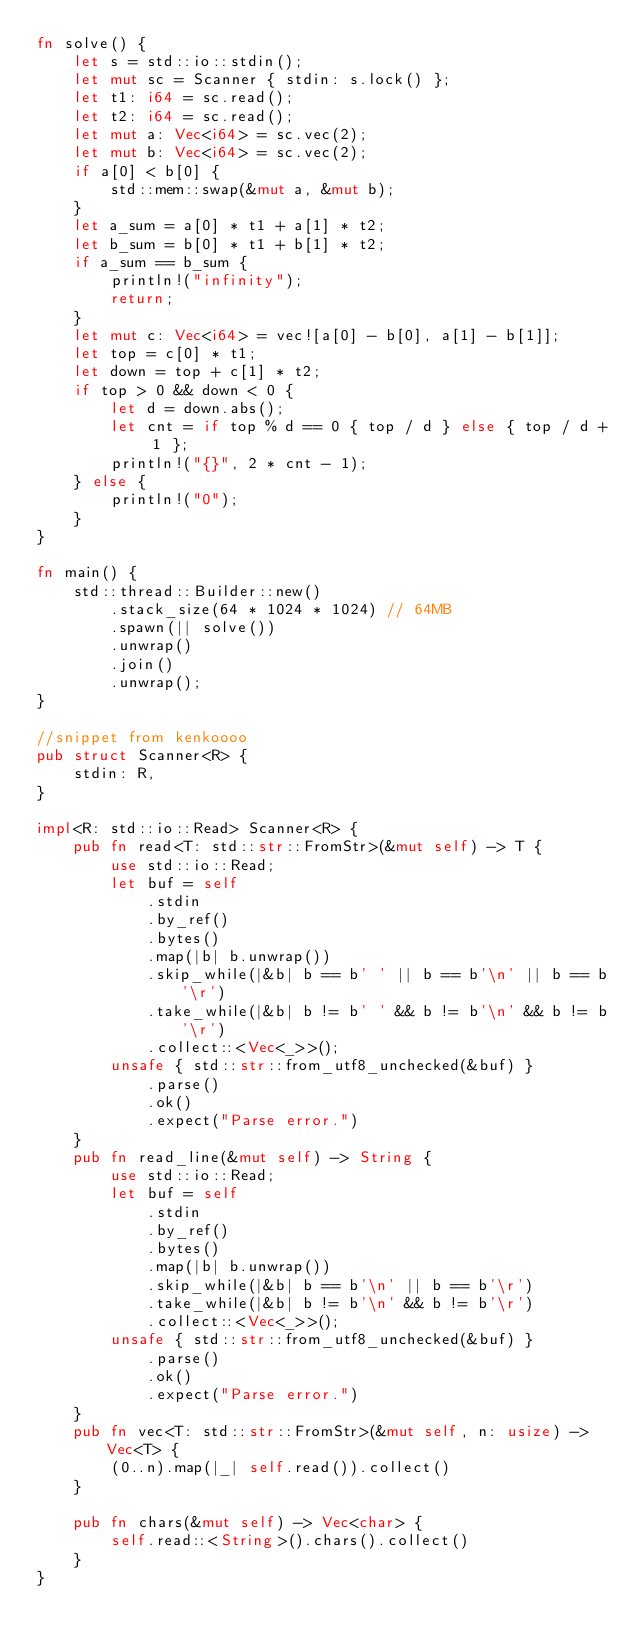<code> <loc_0><loc_0><loc_500><loc_500><_Rust_>fn solve() {
    let s = std::io::stdin();
    let mut sc = Scanner { stdin: s.lock() };
    let t1: i64 = sc.read();
    let t2: i64 = sc.read();
    let mut a: Vec<i64> = sc.vec(2);
    let mut b: Vec<i64> = sc.vec(2);
    if a[0] < b[0] {
        std::mem::swap(&mut a, &mut b);
    }
    let a_sum = a[0] * t1 + a[1] * t2;
    let b_sum = b[0] * t1 + b[1] * t2;
    if a_sum == b_sum {
        println!("infinity");
        return;
    }
    let mut c: Vec<i64> = vec![a[0] - b[0], a[1] - b[1]];
    let top = c[0] * t1;
    let down = top + c[1] * t2;
    if top > 0 && down < 0 {
        let d = down.abs();
        let cnt = if top % d == 0 { top / d } else { top / d + 1 };
        println!("{}", 2 * cnt - 1);
    } else {
        println!("0");
    }
}

fn main() {
    std::thread::Builder::new()
        .stack_size(64 * 1024 * 1024) // 64MB
        .spawn(|| solve())
        .unwrap()
        .join()
        .unwrap();
}

//snippet from kenkoooo
pub struct Scanner<R> {
    stdin: R,
}

impl<R: std::io::Read> Scanner<R> {
    pub fn read<T: std::str::FromStr>(&mut self) -> T {
        use std::io::Read;
        let buf = self
            .stdin
            .by_ref()
            .bytes()
            .map(|b| b.unwrap())
            .skip_while(|&b| b == b' ' || b == b'\n' || b == b'\r')
            .take_while(|&b| b != b' ' && b != b'\n' && b != b'\r')
            .collect::<Vec<_>>();
        unsafe { std::str::from_utf8_unchecked(&buf) }
            .parse()
            .ok()
            .expect("Parse error.")
    }
    pub fn read_line(&mut self) -> String {
        use std::io::Read;
        let buf = self
            .stdin
            .by_ref()
            .bytes()
            .map(|b| b.unwrap())
            .skip_while(|&b| b == b'\n' || b == b'\r')
            .take_while(|&b| b != b'\n' && b != b'\r')
            .collect::<Vec<_>>();
        unsafe { std::str::from_utf8_unchecked(&buf) }
            .parse()
            .ok()
            .expect("Parse error.")
    }
    pub fn vec<T: std::str::FromStr>(&mut self, n: usize) -> Vec<T> {
        (0..n).map(|_| self.read()).collect()
    }

    pub fn chars(&mut self) -> Vec<char> {
        self.read::<String>().chars().collect()
    }
}
</code> 